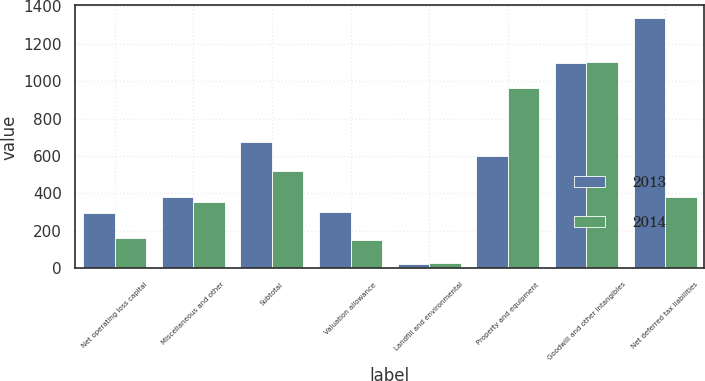Convert chart. <chart><loc_0><loc_0><loc_500><loc_500><stacked_bar_chart><ecel><fcel>Net operating loss capital<fcel>Miscellaneous and other<fcel>Subtotal<fcel>Valuation allowance<fcel>Landfill and environmental<fcel>Property and equipment<fcel>Goodwill and other intangibles<fcel>Net deferred tax liabilities<nl><fcel>2013<fcel>297<fcel>380<fcel>677<fcel>300<fcel>22<fcel>598<fcel>1095<fcel>1338<nl><fcel>2014<fcel>164<fcel>356<fcel>520<fcel>149<fcel>30<fcel>966<fcel>1104<fcel>380<nl></chart> 